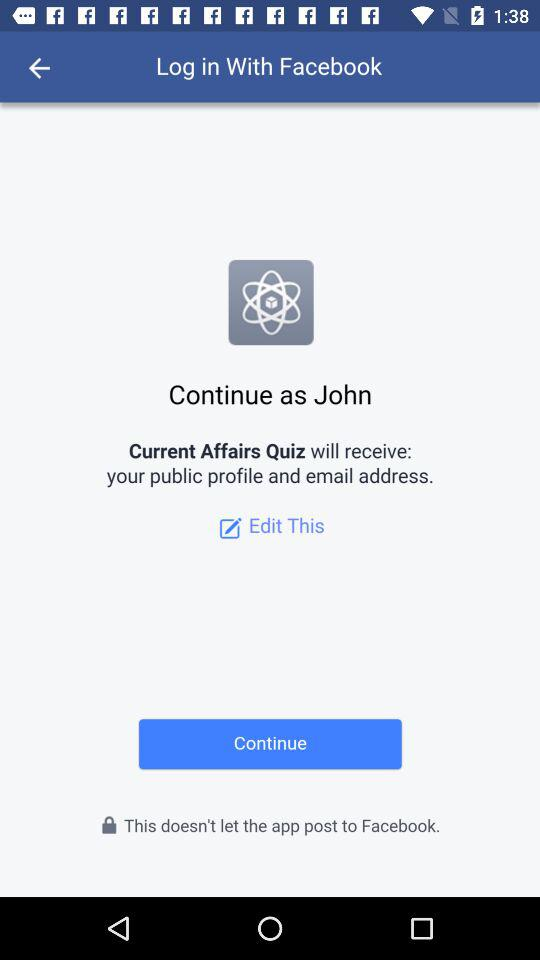What is the name of the user? The name of the user is John. 